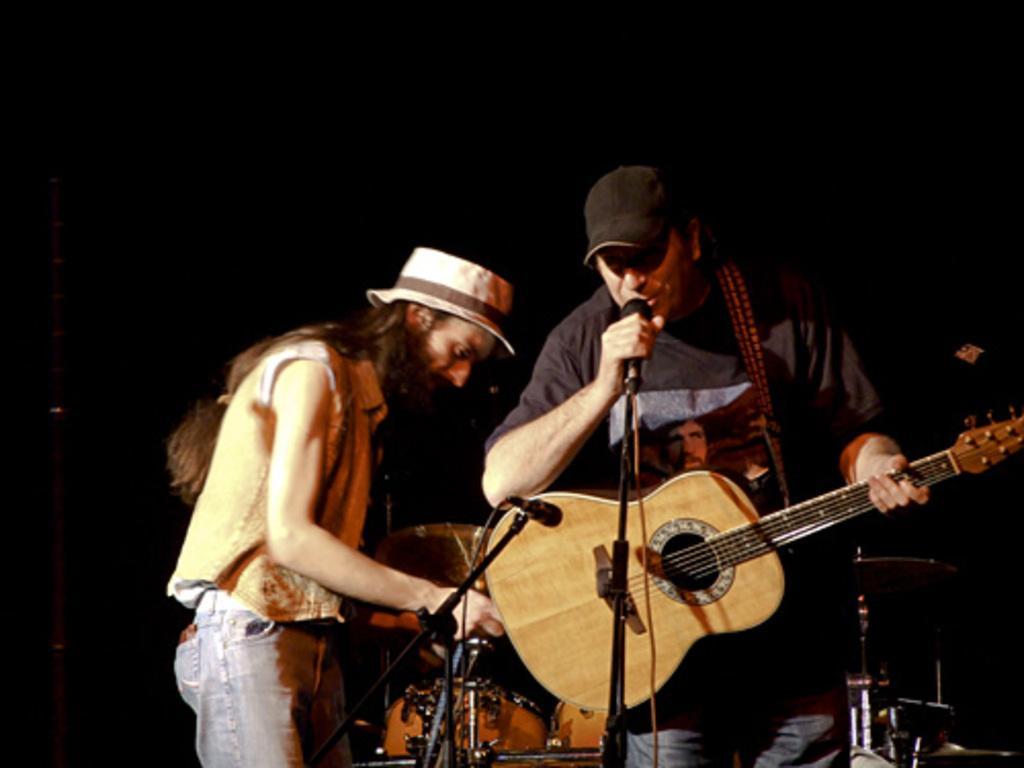Please provide a concise description of this image. In this image there are 2 persons , 1 person is standing and playing a guitar and singing a song in the microphone , another person standing beside him and at the back ground there are drums and there is a dark background. 